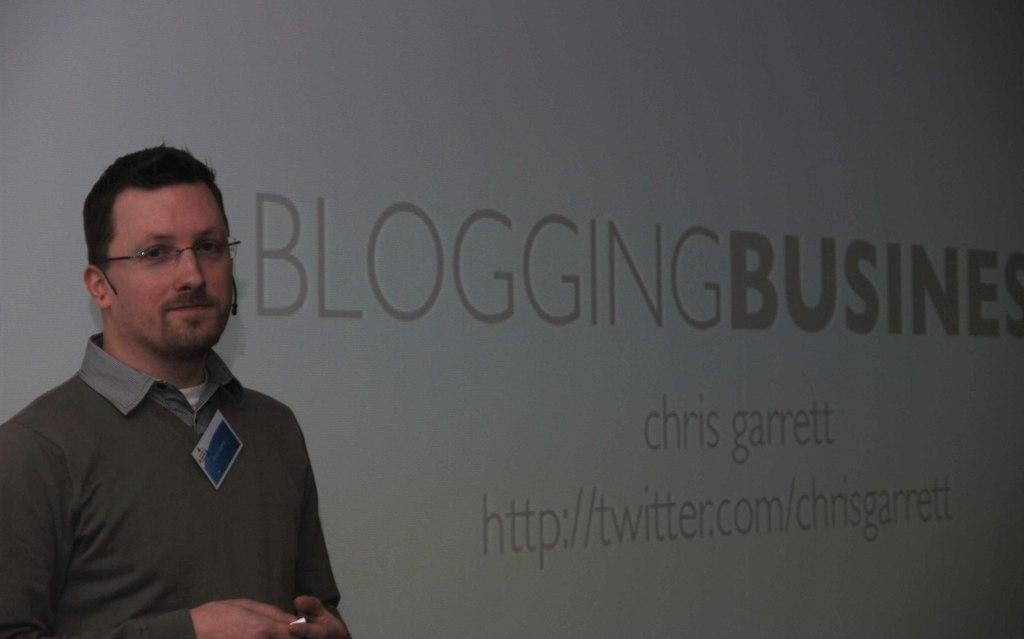What is the man in the image doing? The man is standing in the image. What is the man's facial expression? The man is smiling. What is the man wearing on his upper body? The man is wearing a shirt. What accessory is the man wearing on his face? The man is wearing spectacles. What object can be seen in the image that might indicate a profession or affiliation? There is a badge in the image. What can be seen in the background of the image that contains letters? There is a hoarding with letters in the image. Where is the nest of the wild birds in the image? There is no nest or wild birds present in the image. 